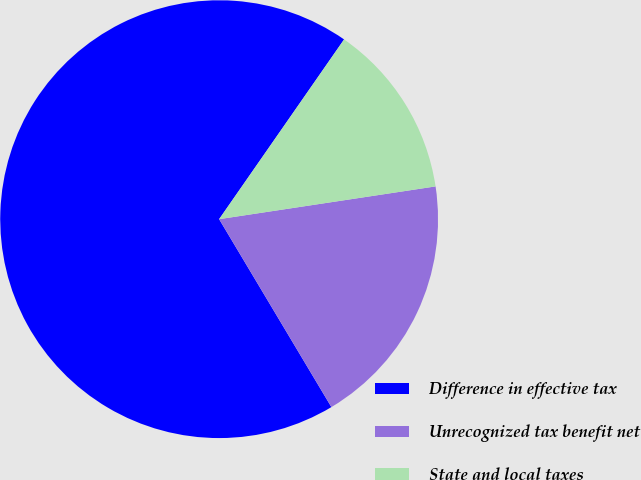Convert chart. <chart><loc_0><loc_0><loc_500><loc_500><pie_chart><fcel>Difference in effective tax<fcel>Unrecognized tax benefit net<fcel>State and local taxes<nl><fcel>68.24%<fcel>18.82%<fcel>12.94%<nl></chart> 